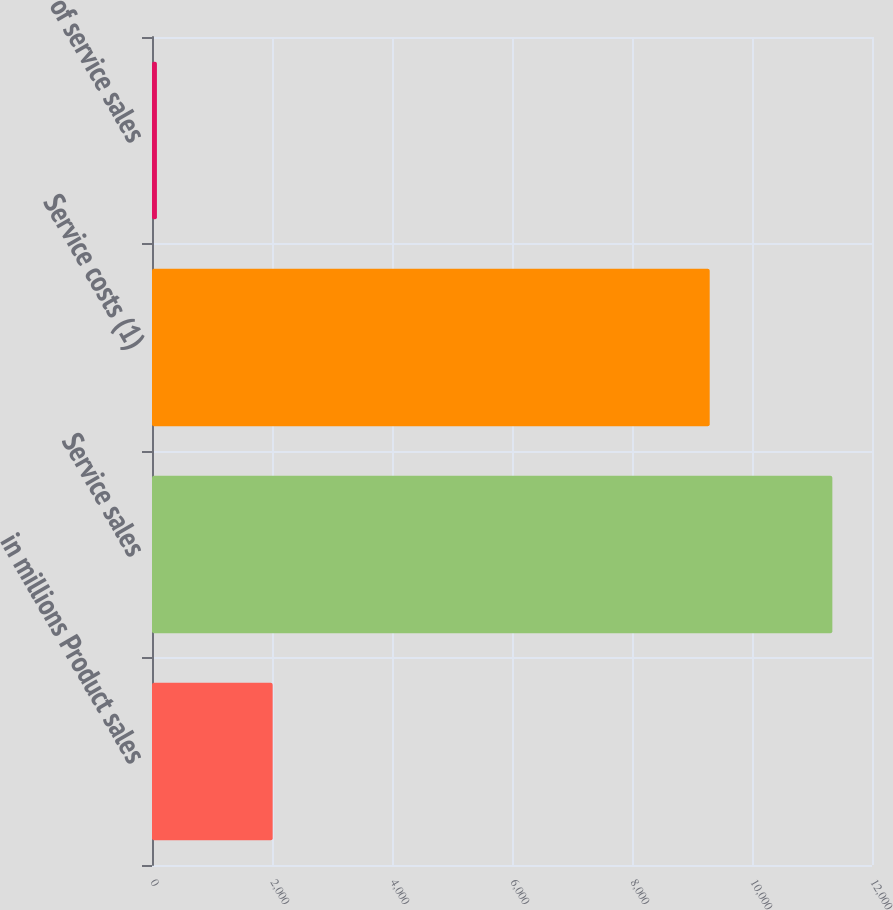Convert chart. <chart><loc_0><loc_0><loc_500><loc_500><bar_chart><fcel>in millions Product sales<fcel>Service sales<fcel>Service costs (1)<fcel>of service sales<nl><fcel>2011<fcel>11339<fcel>9295<fcel>82<nl></chart> 